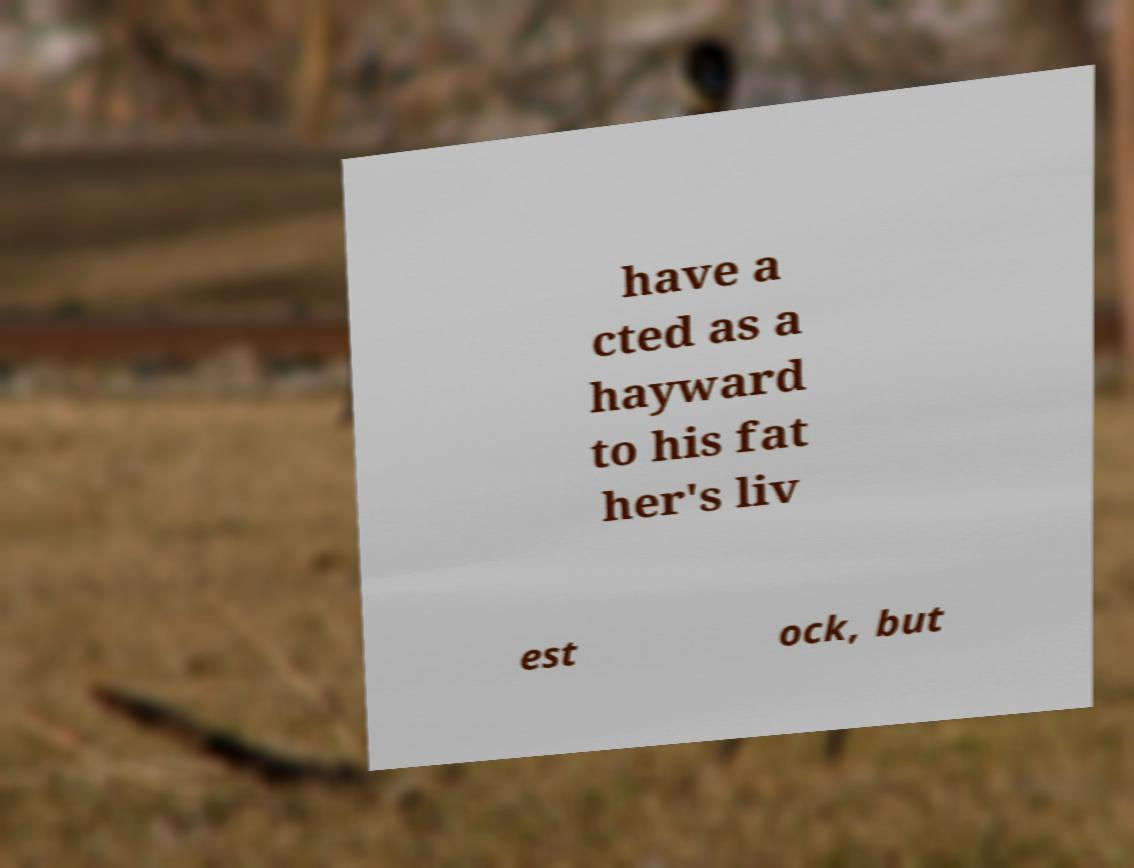There's text embedded in this image that I need extracted. Can you transcribe it verbatim? have a cted as a hayward to his fat her's liv est ock, but 